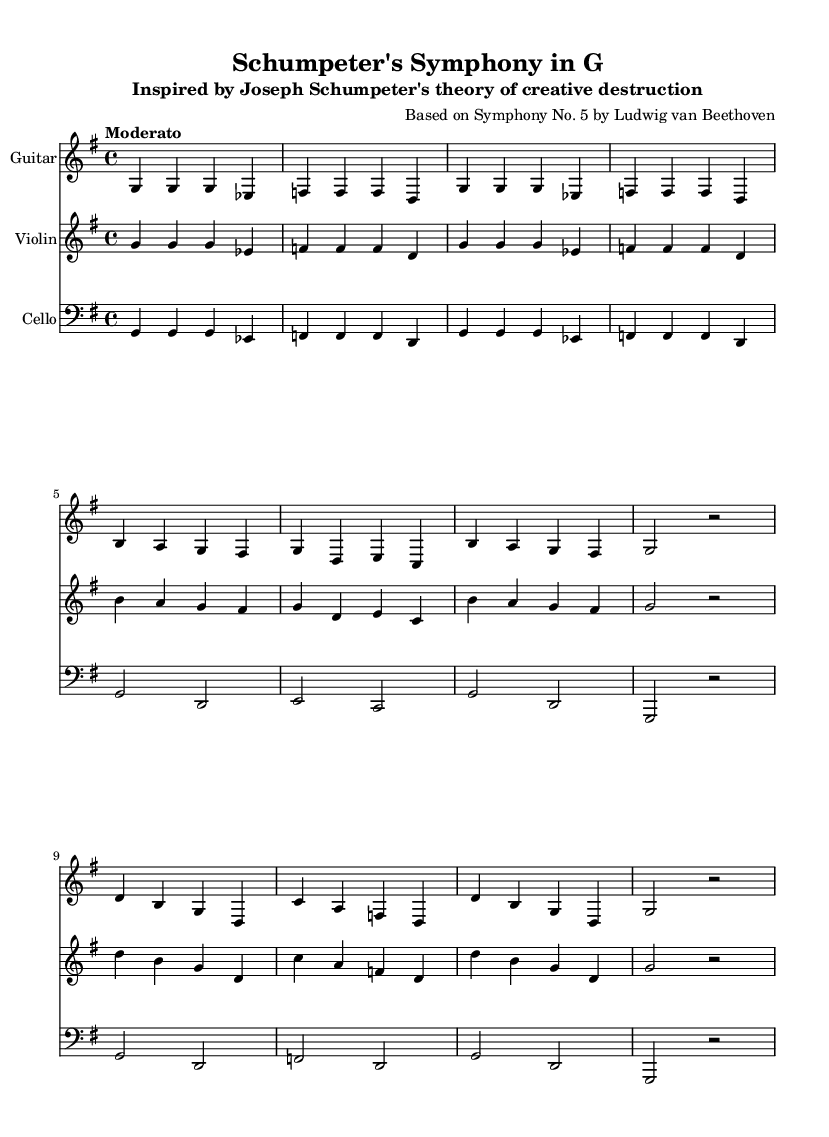What is the key signature of this music? The key signature indicates the presence of one sharp (F#), which means the piece is in G major.
Answer: G major What is the time signature of this music? The time signature appears at the beginning and is clearly marked as 4/4, indicating four beats per measure.
Answer: 4/4 What is the tempo marking for this piece? The tempo marking is located above the staff and is indicated as "Moderato," which suggests a moderate pace.
Answer: Moderato How many instruments are featured in the score? By examining the score, we see three groups labeled: Guitar, Violin, and Cello, indicating that there are three instruments.
Answer: Three In which section does the phrase "g g g ees" appear? The phrase is part of both the Intro and the Verse sections, as shown in the musical notation.
Answer: Intro and Verse What is the relationship between the Guitar and Violin parts? Both the Guitar and Violin parts share the same melodic line and rhythm, reinforcing the theme of the piece.
Answer: Same melodic line What is the role of the Cello in this arrangement? The Cello supports the harmonic foundation and provides a bass line, which is characteristic in ensemble arrangements.
Answer: Bass line 